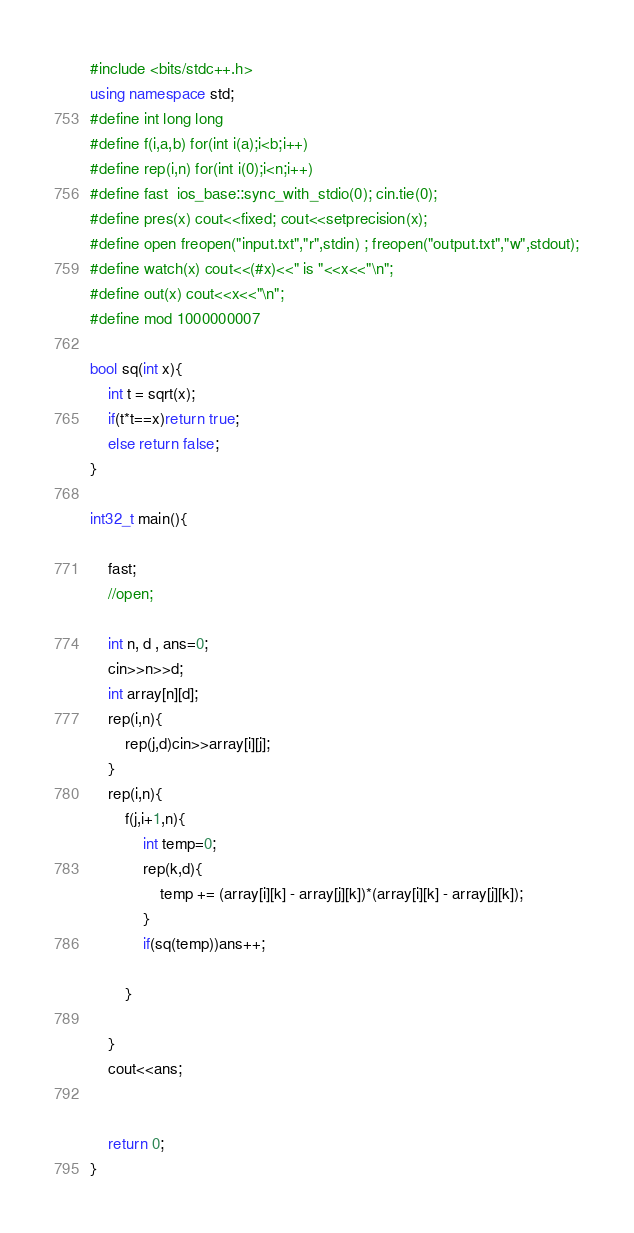Convert code to text. <code><loc_0><loc_0><loc_500><loc_500><_C++_>#include <bits/stdc++.h>
using namespace std;
#define int long long
#define f(i,a,b) for(int i(a);i<b;i++)
#define rep(i,n) for(int i(0);i<n;i++)
#define fast  ios_base::sync_with_stdio(0); cin.tie(0);
#define pres(x) cout<<fixed; cout<<setprecision(x);
#define open freopen("input.txt","r",stdin) ; freopen("output.txt","w",stdout);
#define watch(x) cout<<(#x)<<" is "<<x<<"\n";
#define out(x) cout<<x<<"\n";
#define mod 1000000007

bool sq(int x){
	int t = sqrt(x);
	if(t*t==x)return true;
	else return false;
}

int32_t main(){
	
	fast;
	//open;

	int n, d , ans=0;
	cin>>n>>d;
	int array[n][d];
	rep(i,n){
		rep(j,d)cin>>array[i][j];
	}
	rep(i,n){
		f(j,i+1,n){
			int temp=0;
			rep(k,d){
				temp += (array[i][k] - array[j][k])*(array[i][k] - array[j][k]);
			}
			if(sq(temp))ans++;

		}

	}
	cout<<ans;


	return 0;
}</code> 